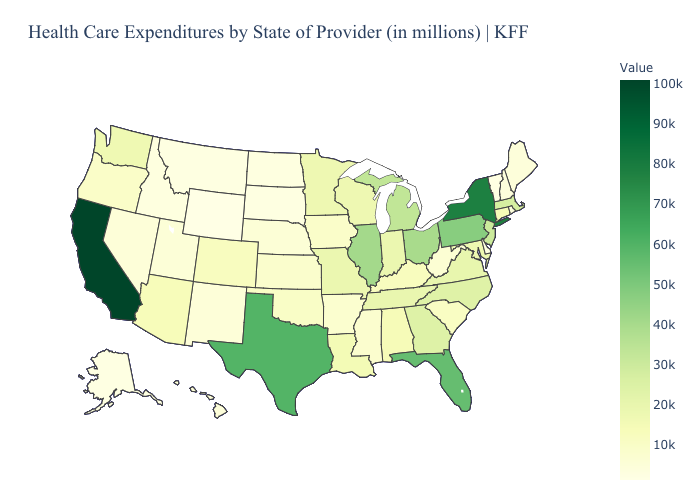Does the map have missing data?
Concise answer only. No. Does Wyoming have the lowest value in the USA?
Give a very brief answer. Yes. Among the states that border Maryland , which have the lowest value?
Keep it brief. Delaware. Which states have the highest value in the USA?
Write a very short answer. California. 